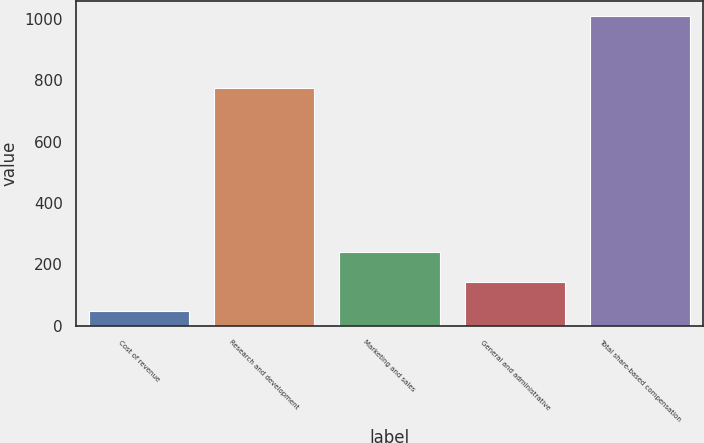Convert chart to OTSL. <chart><loc_0><loc_0><loc_500><loc_500><bar_chart><fcel>Cost of revenue<fcel>Research and development<fcel>Marketing and sales<fcel>General and administrative<fcel>Total share-based compensation<nl><fcel>47<fcel>776<fcel>239.6<fcel>143.3<fcel>1010<nl></chart> 